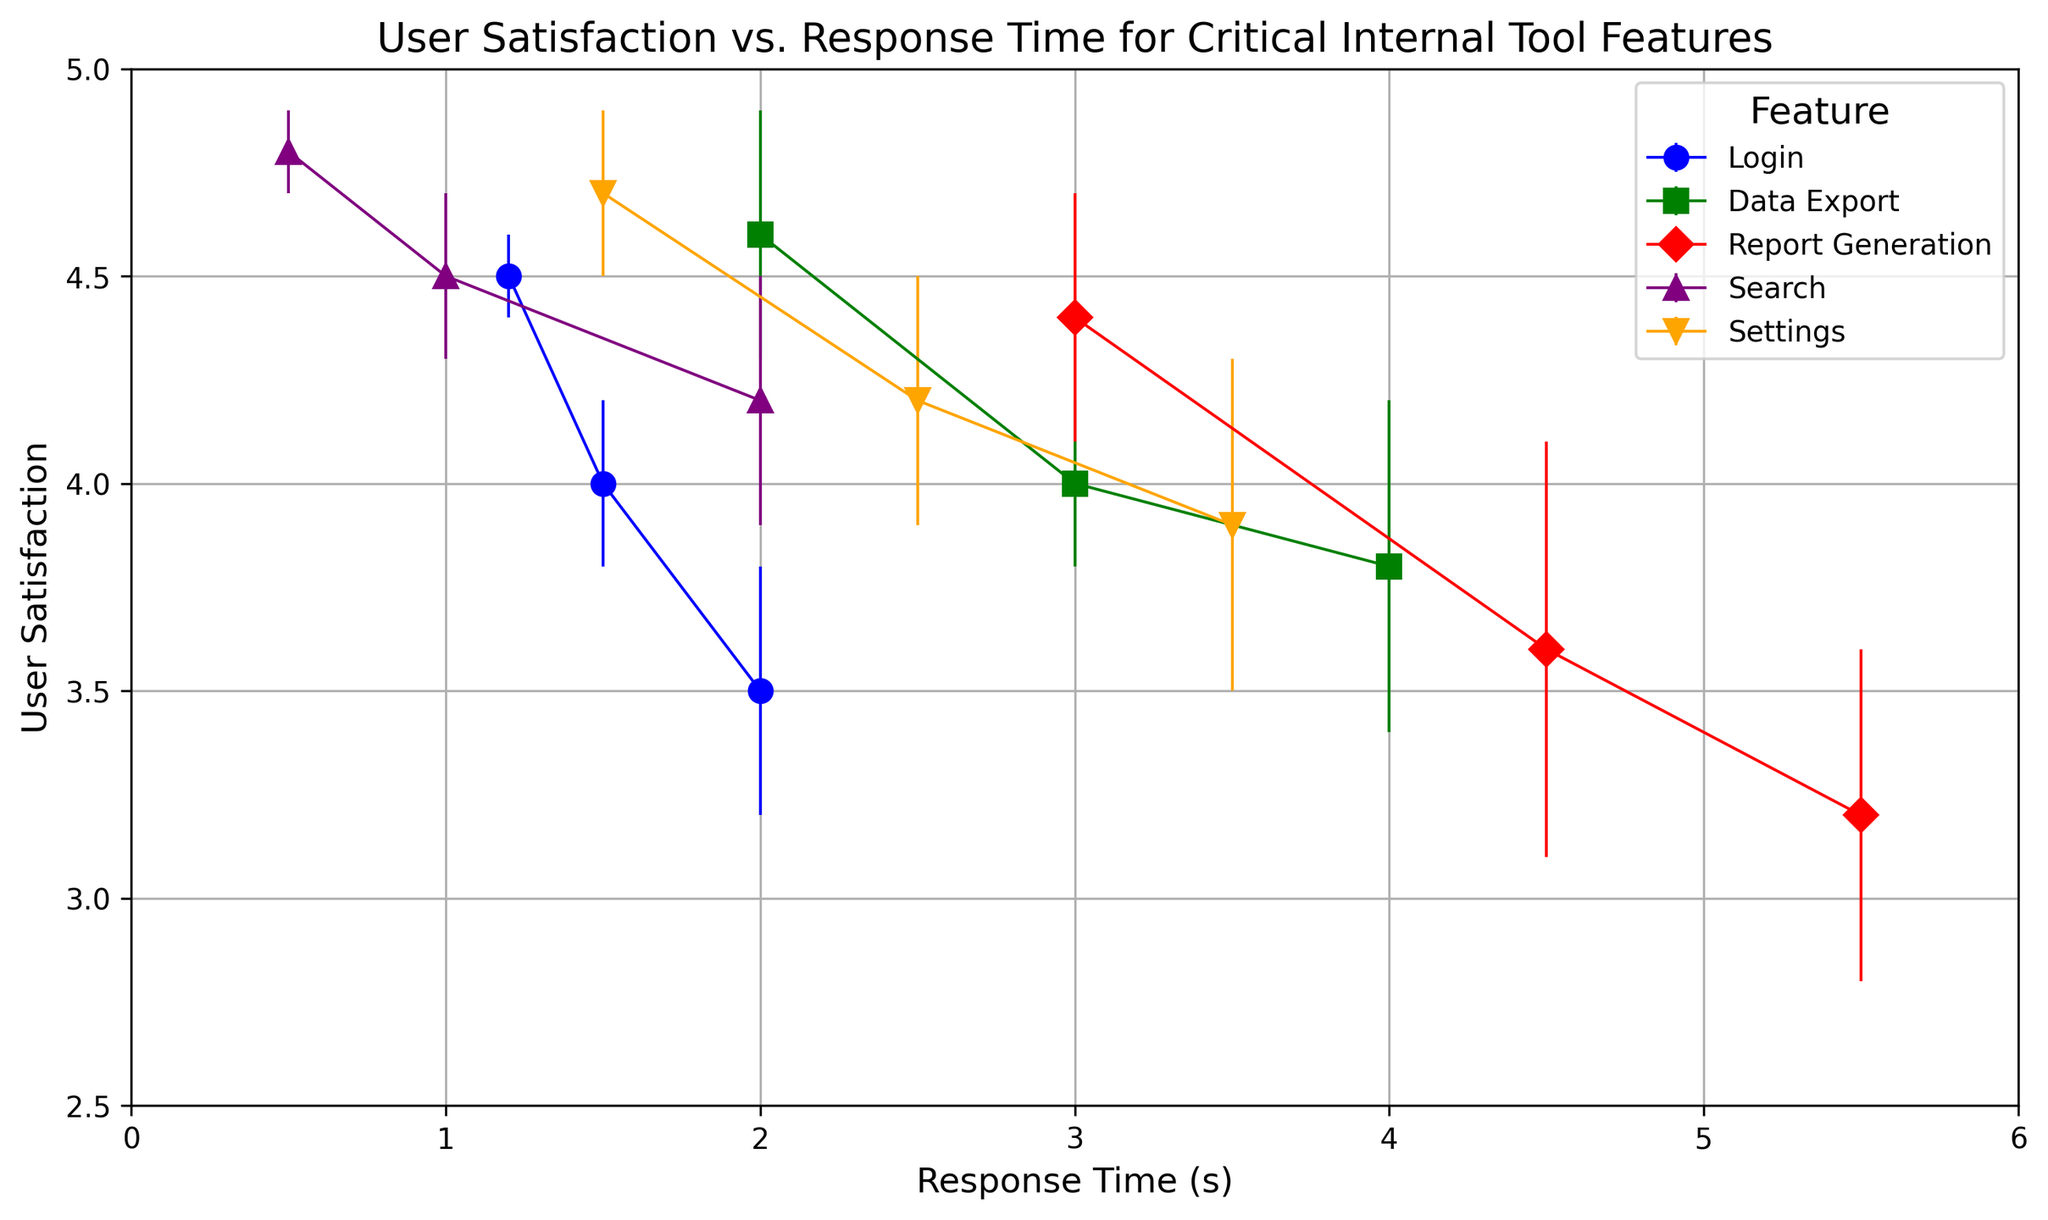What's the response time range for the "Login" feature in the chart? By visual inspection, the "Login" feature data points are spread along the X-axis. The minimum and maximum response times for "Login" can be found by checking the leftmost and rightmost points respectively.
Answer: 1.2 to 2.0 seconds Which feature has the highest user satisfaction at a specific response time, and what is that response time? The highest user satisfaction is indicated by the highest point on the Y-axis. The "Search" feature has the highest user satisfaction at a response time of 0.5 seconds.
Answer: Search, 0.5 seconds Compare the user satisfaction for "Report Generation" at 3.0 seconds and "Login" at 2.0 seconds. Which is higher? Locate the data points for "Report Generation" at 3.0 seconds and "Login" at 2.0 seconds on the plot, then compare their Y-axis values. "Report Generation" at 3.0 seconds shows higher user satisfaction.
Answer: Report Generation What is the average user satisfaction for the "Data Export" feature? Identify the user satisfaction values for "Data Export" feature (4.6, 4.0, 3.8). Sum these values and divide by the number of points (3). (4.6 + 4.0 + 3.8) / 3 = 4.13
Answer: 4.13 For "Settings" feature, what's the difference in user satisfaction between response times of 1.5 seconds and 3.5 seconds? Find the user satisfaction values for "Settings" at 1.5 seconds (4.7) and 3.5 seconds (3.9). Subtract the smaller value from the larger value. 4.7 - 3.9 = 0.8
Answer: 0.8 Which feature shows the most consistent user satisfaction, taking error bars into account? Check the length of error bars for different features. The "Settings" feature has the smallest and most consistent error bars.
Answer: Settings Which feature has the greatest decrease in user satisfaction as response time increases? Identify the feature where user satisfaction drops most drastically when moving from lower to higher response times. The "Report Generation" feature shows the steepest decline.
Answer: Report Generation What's the response time for "Search" when user satisfaction is 4.2? Locate the data point for the "Search" feature with a user satisfaction of 4.2 on the Y-axis and note the corresponding response time on the X-axis.
Answer: 2.0 seconds How much higher is user satisfaction for "Search" at 1.0 second compared to "Data Export" at 4.0 seconds? Identify the user satisfaction values for "Search" at 1.0 second (4.5) and "Data Export" at 4.0 seconds (3.8). Subtract the smaller value from the larger value. 4.5 - 3.8 = 0.7
Answer: 0.7 Between "Login" at 1.5 seconds and "Data Export" at 3.0 seconds, which has lower user satisfaction and by how much? Find the user satisfaction values for "Login" at 1.5 seconds (4.0) and "Data Export" at 3.0 seconds (4.0). Both values are the same.
Answer: They are equal 